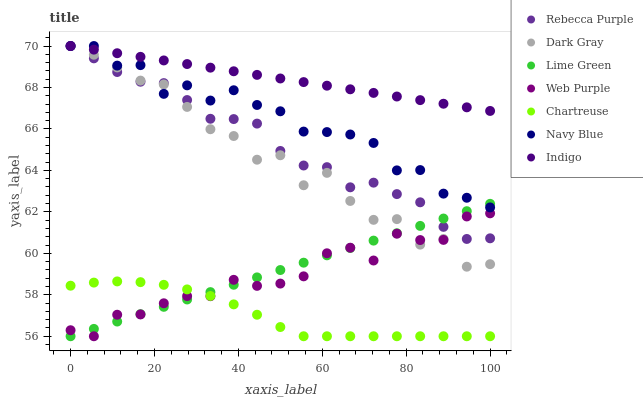Does Chartreuse have the minimum area under the curve?
Answer yes or no. Yes. Does Indigo have the maximum area under the curve?
Answer yes or no. Yes. Does Navy Blue have the minimum area under the curve?
Answer yes or no. No. Does Navy Blue have the maximum area under the curve?
Answer yes or no. No. Is Indigo the smoothest?
Answer yes or no. Yes. Is Dark Gray the roughest?
Answer yes or no. Yes. Is Navy Blue the smoothest?
Answer yes or no. No. Is Navy Blue the roughest?
Answer yes or no. No. Does Chartreuse have the lowest value?
Answer yes or no. Yes. Does Navy Blue have the lowest value?
Answer yes or no. No. Does Rebecca Purple have the highest value?
Answer yes or no. Yes. Does Chartreuse have the highest value?
Answer yes or no. No. Is Web Purple less than Navy Blue?
Answer yes or no. Yes. Is Rebecca Purple greater than Chartreuse?
Answer yes or no. Yes. Does Dark Gray intersect Web Purple?
Answer yes or no. Yes. Is Dark Gray less than Web Purple?
Answer yes or no. No. Is Dark Gray greater than Web Purple?
Answer yes or no. No. Does Web Purple intersect Navy Blue?
Answer yes or no. No. 